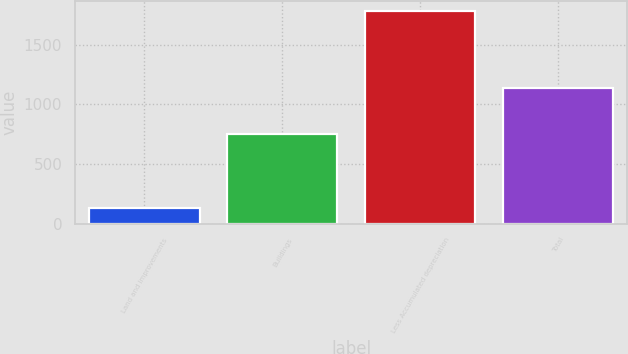Convert chart. <chart><loc_0><loc_0><loc_500><loc_500><bar_chart><fcel>Land and improvements<fcel>Buildings<fcel>Less Accumulated depreciation<fcel>Total<nl><fcel>130<fcel>754<fcel>1780<fcel>1139<nl></chart> 